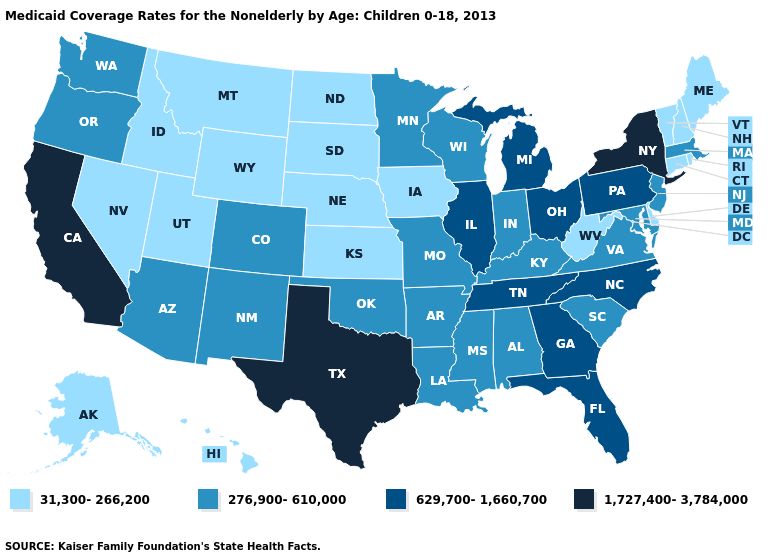Does Maryland have a higher value than Texas?
Write a very short answer. No. What is the value of Maryland?
Give a very brief answer. 276,900-610,000. Name the states that have a value in the range 1,727,400-3,784,000?
Concise answer only. California, New York, Texas. Name the states that have a value in the range 276,900-610,000?
Quick response, please. Alabama, Arizona, Arkansas, Colorado, Indiana, Kentucky, Louisiana, Maryland, Massachusetts, Minnesota, Mississippi, Missouri, New Jersey, New Mexico, Oklahoma, Oregon, South Carolina, Virginia, Washington, Wisconsin. How many symbols are there in the legend?
Write a very short answer. 4. What is the highest value in the South ?
Quick response, please. 1,727,400-3,784,000. Name the states that have a value in the range 1,727,400-3,784,000?
Quick response, please. California, New York, Texas. What is the highest value in the USA?
Quick response, please. 1,727,400-3,784,000. Is the legend a continuous bar?
Write a very short answer. No. Which states hav the highest value in the Northeast?
Quick response, please. New York. Does the map have missing data?
Be succinct. No. What is the value of South Carolina?
Write a very short answer. 276,900-610,000. Name the states that have a value in the range 629,700-1,660,700?
Be succinct. Florida, Georgia, Illinois, Michigan, North Carolina, Ohio, Pennsylvania, Tennessee. Name the states that have a value in the range 629,700-1,660,700?
Write a very short answer. Florida, Georgia, Illinois, Michigan, North Carolina, Ohio, Pennsylvania, Tennessee. Among the states that border Tennessee , does Virginia have the highest value?
Give a very brief answer. No. 